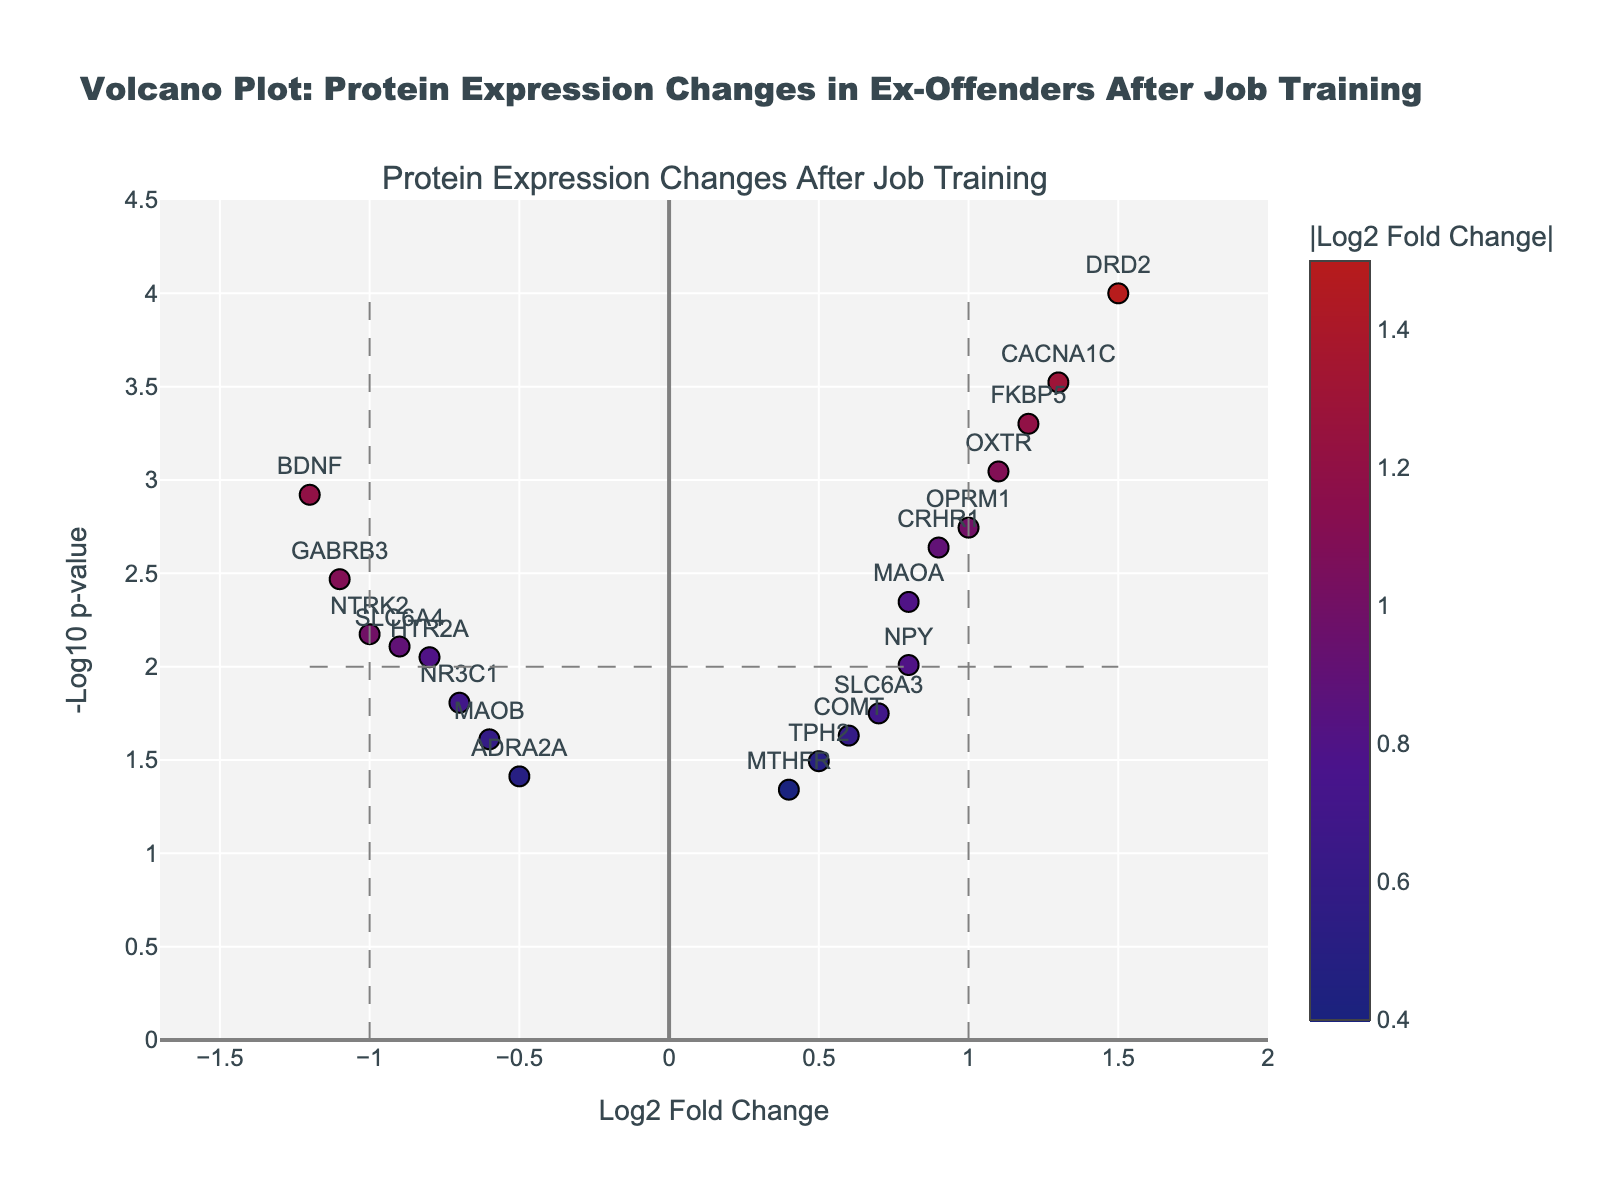What is the title of the plot? The title is located at the top center of the plot and provides a description of the plot’s main purpose. In this case, it is "Volcano Plot: Protein Expression Changes in Ex-Offenders After Job Training."
Answer: Volcano Plot: Protein Expression Changes in Ex-Offenders After Job Training What are the axis labels? The axis labels are found at the ends of the x and y axes. The x-axis is labeled "Log2 Fold Change," and the y-axis is labeled "-Log10 p-value."
Answer: x: Log2 Fold Change, y: -Log10 p-value How many proteins show significant changes in expression? Proteins are considered significant if they exceed the thresholds shown by dashed lines: Log2 Fold Change > 1 or < -1 and -Log10 p-value > 2 (which corresponds to p-value < 0.01). Visual inspection indicates that 6 proteins meet these criteria.
Answer: 6 Which protein has the highest log2 fold change and what is its significance level? The protein with the highest x-axis value is DRD2 with a log2 fold change of 1.5. The y-axis value (or -log10 p-value) for DRD2 appears to be around 4, indicating very high significance.
Answer: DRD2, very significant How many proteins have a log2 fold change between -1 and 1? Proteins within this range are between the vertical dashed lines at -1 and 1 on the x-axis. There are 10 such proteins.
Answer: 10 Which protein has the lowest p-value? The protein with the highest y-axis value (since -log10(p-value) is plotted) is DRD2, suggesting it has the lowest p-value.
Answer: DRD2 What is the color scale indication for the markers? The color of the markers represents the absolute value of the log2 fold change, with different shades indicating the magnitude.
Answer: Magnitude of log2 fold change Are there more upregulated or downregulated proteins? By comparing the number of markers to the right of 0 (upregulated) and to the left of 0 (downregulated), it appears there are more upregulated proteins.
Answer: More upregulated Does any protein meet both significance thresholds but show a decrease in expression? Yes, proteins that meet both thresholds and have a negative log2 fold change (left of vertical line at -1) include BDNF and GABRB3.
Answer: Yes, BDNF and GABRB3 Which protein has the closest to average log2 fold change? The average log2 fold change can be estimated by visual inspection. SLC6A3 has a log2 fold change close to 0.7, which is close to the average given most values.
Answer: SLC6A3 